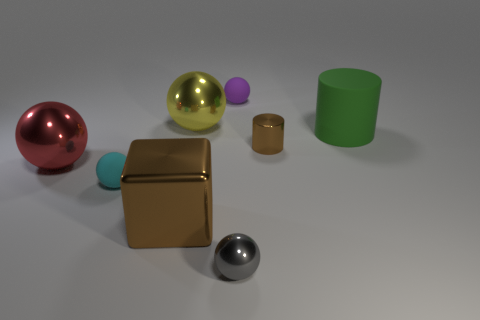Subtract 2 balls. How many balls are left? 3 Subtract all cyan spheres. How many spheres are left? 4 Subtract all blue balls. Subtract all yellow cubes. How many balls are left? 5 Add 1 tiny shiny cylinders. How many objects exist? 9 Subtract all cylinders. How many objects are left? 6 Subtract 1 red balls. How many objects are left? 7 Subtract all large balls. Subtract all big red metallic balls. How many objects are left? 5 Add 4 tiny cylinders. How many tiny cylinders are left? 5 Add 4 large gray cubes. How many large gray cubes exist? 4 